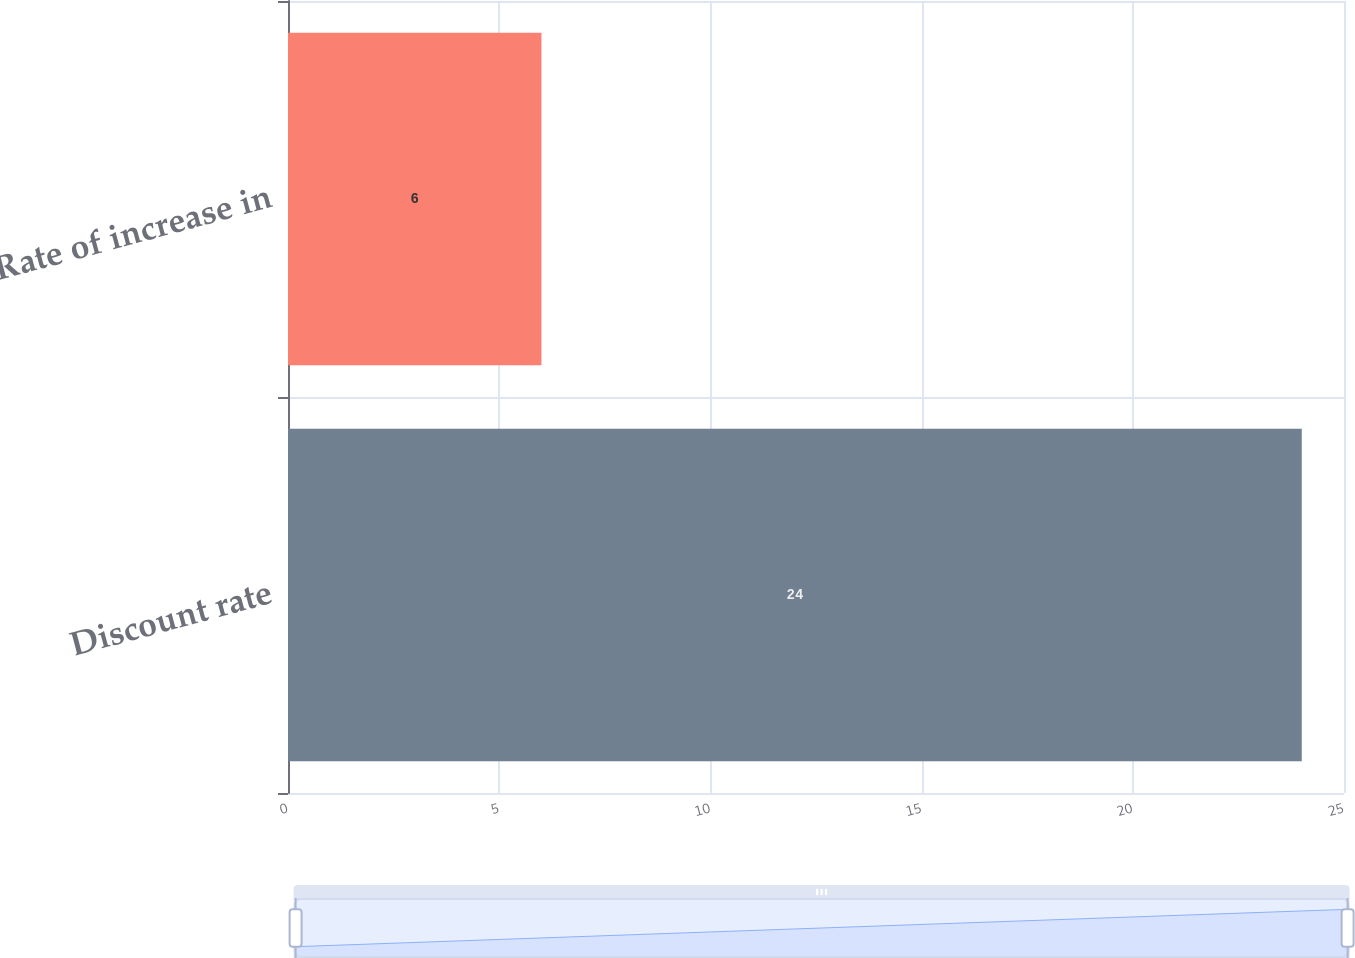Convert chart to OTSL. <chart><loc_0><loc_0><loc_500><loc_500><bar_chart><fcel>Discount rate<fcel>Rate of increase in<nl><fcel>24<fcel>6<nl></chart> 